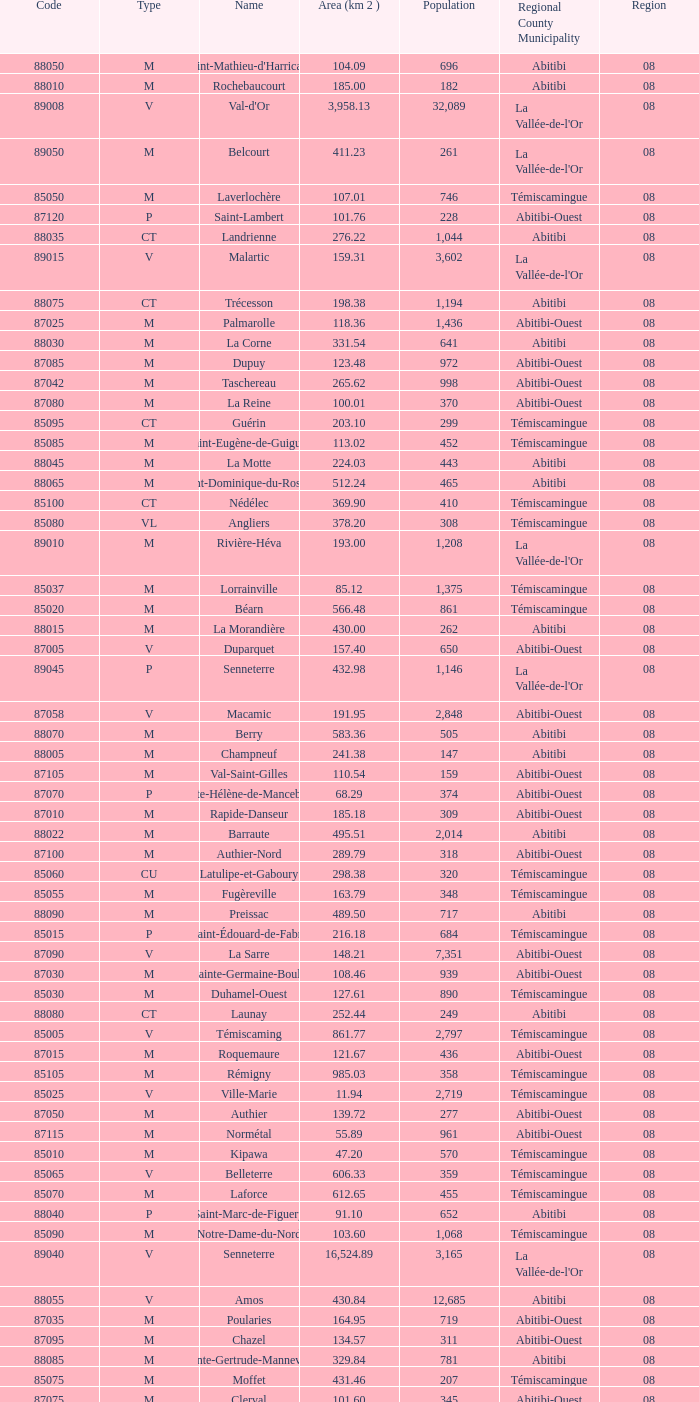What type has a population of 370? M. 